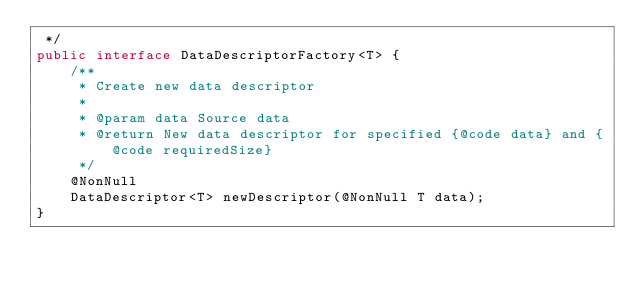Convert code to text. <code><loc_0><loc_0><loc_500><loc_500><_Java_> */
public interface DataDescriptorFactory<T> {
    /**
     * Create new data descriptor
     *
     * @param data Source data
     * @return New data descriptor for specified {@code data} and {@code requiredSize}
     */
    @NonNull
    DataDescriptor<T> newDescriptor(@NonNull T data);
}
</code> 